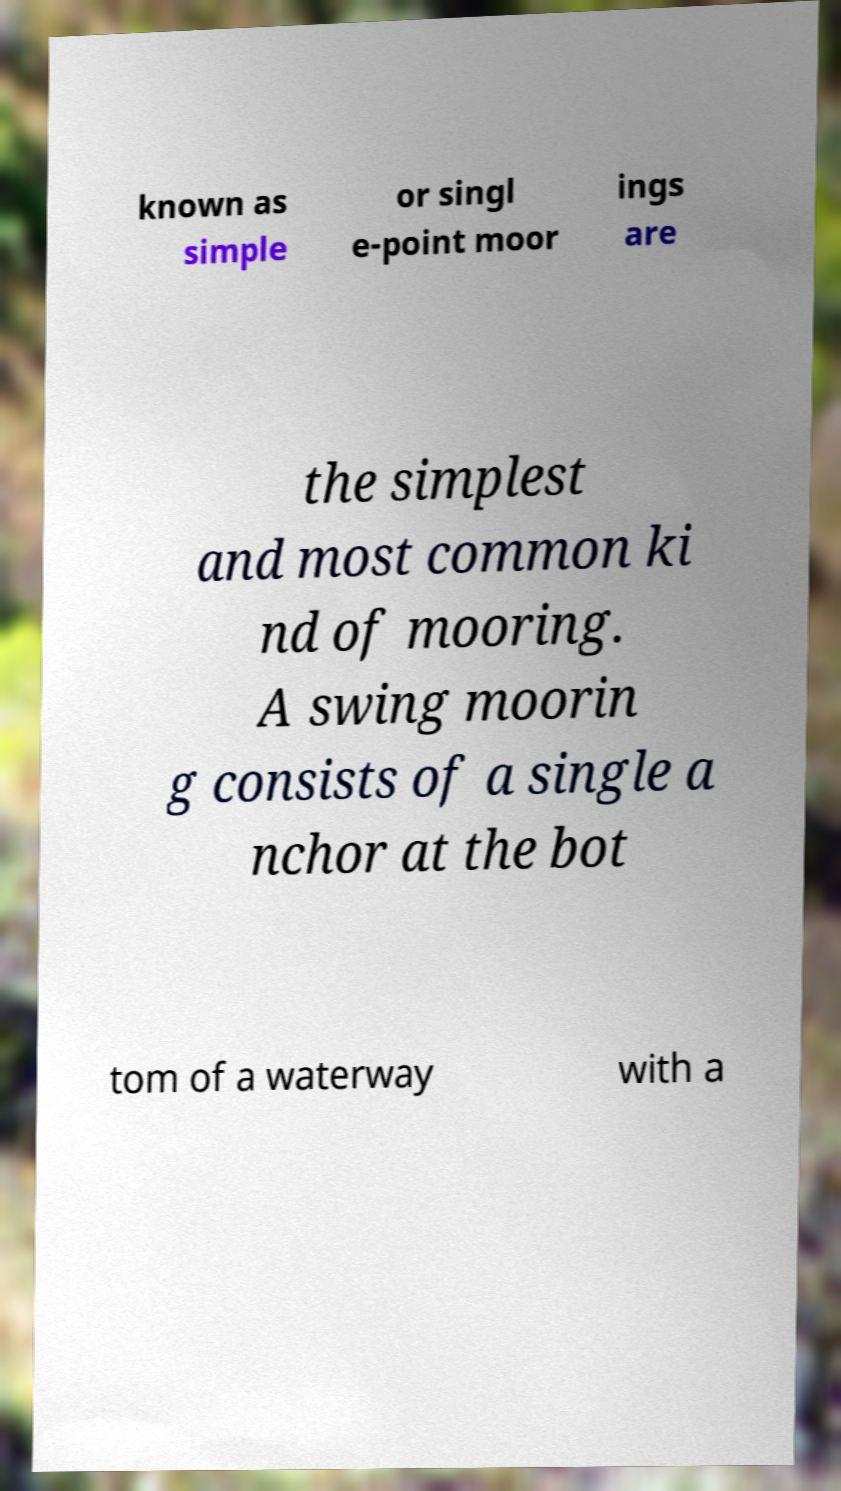Can you accurately transcribe the text from the provided image for me? known as simple or singl e-point moor ings are the simplest and most common ki nd of mooring. A swing moorin g consists of a single a nchor at the bot tom of a waterway with a 